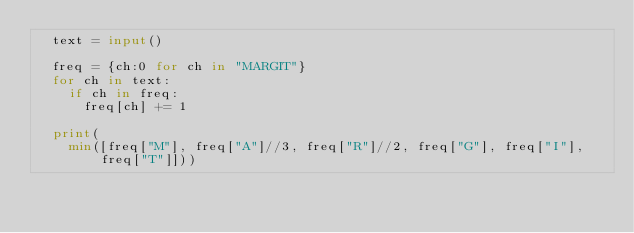<code> <loc_0><loc_0><loc_500><loc_500><_Python_>  text = input()

  freq = {ch:0 for ch in "MARGIT"}
  for ch in text:
    if ch in freq:
      freq[ch] += 1
  
  print(
    min([freq["M"], freq["A"]//3, freq["R"]//2, freq["G"], freq["I"], freq["T"]]))
  </code> 